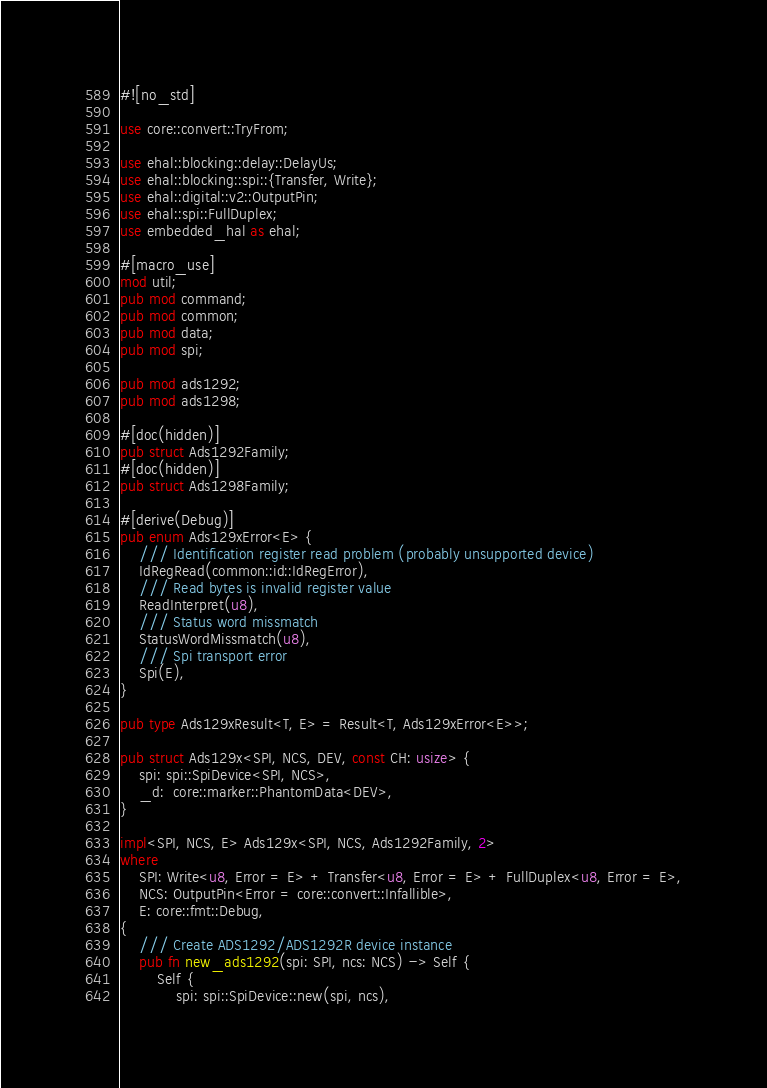Convert code to text. <code><loc_0><loc_0><loc_500><loc_500><_Rust_>#![no_std]

use core::convert::TryFrom;

use ehal::blocking::delay::DelayUs;
use ehal::blocking::spi::{Transfer, Write};
use ehal::digital::v2::OutputPin;
use ehal::spi::FullDuplex;
use embedded_hal as ehal;

#[macro_use]
mod util;
pub mod command;
pub mod common;
pub mod data;
pub mod spi;

pub mod ads1292;
pub mod ads1298;

#[doc(hidden)]
pub struct Ads1292Family;
#[doc(hidden)]
pub struct Ads1298Family;

#[derive(Debug)]
pub enum Ads129xError<E> {
    /// Identification register read problem (probably unsupported device)
    IdRegRead(common::id::IdRegError),
    /// Read bytes is invalid register value
    ReadInterpret(u8),
    /// Status word missmatch
    StatusWordMissmatch(u8),
    /// Spi transport error
    Spi(E),
}

pub type Ads129xResult<T, E> = Result<T, Ads129xError<E>>;

pub struct Ads129x<SPI, NCS, DEV, const CH: usize> {
    spi: spi::SpiDevice<SPI, NCS>,
    _d:  core::marker::PhantomData<DEV>,
}

impl<SPI, NCS, E> Ads129x<SPI, NCS, Ads1292Family, 2>
where
    SPI: Write<u8, Error = E> + Transfer<u8, Error = E> + FullDuplex<u8, Error = E>,
    NCS: OutputPin<Error = core::convert::Infallible>,
    E: core::fmt::Debug,
{
    /// Create ADS1292/ADS1292R device instance
    pub fn new_ads1292(spi: SPI, ncs: NCS) -> Self {
        Self {
            spi: spi::SpiDevice::new(spi, ncs),</code> 